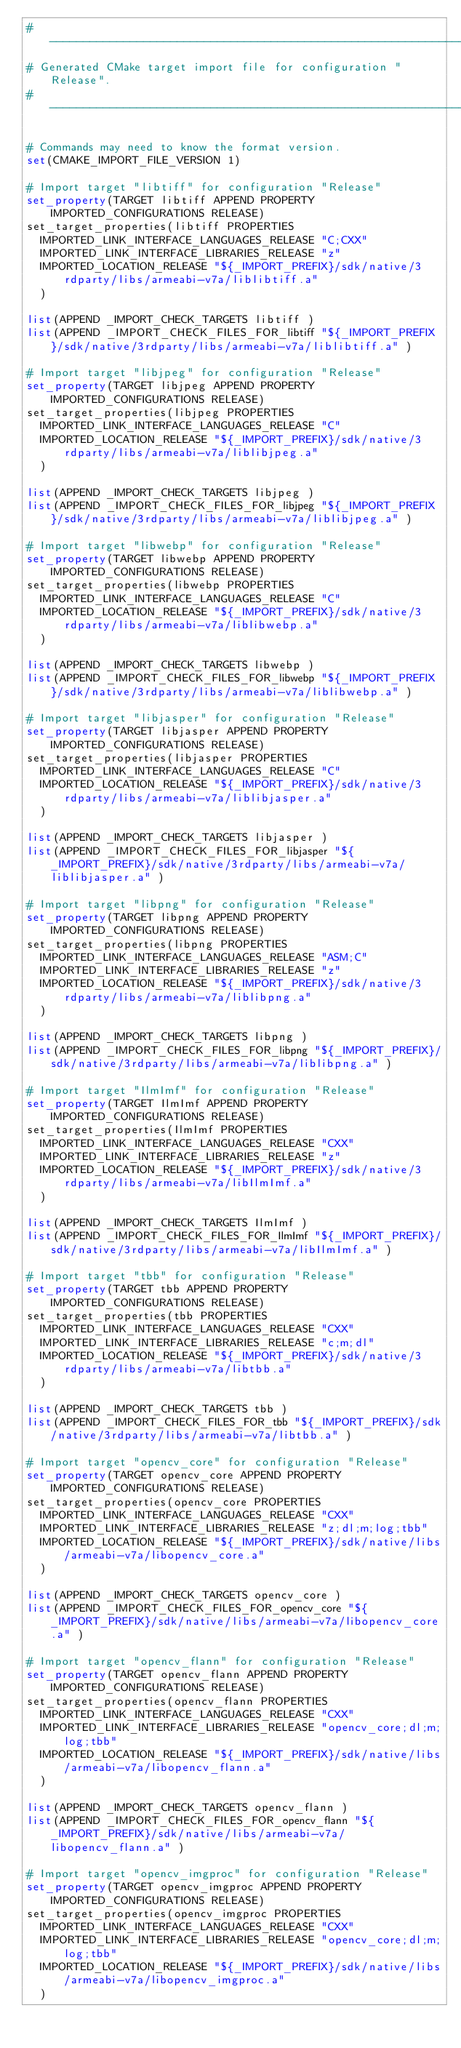Convert code to text. <code><loc_0><loc_0><loc_500><loc_500><_CMake_>#----------------------------------------------------------------
# Generated CMake target import file for configuration "Release".
#----------------------------------------------------------------

# Commands may need to know the format version.
set(CMAKE_IMPORT_FILE_VERSION 1)

# Import target "libtiff" for configuration "Release"
set_property(TARGET libtiff APPEND PROPERTY IMPORTED_CONFIGURATIONS RELEASE)
set_target_properties(libtiff PROPERTIES
  IMPORTED_LINK_INTERFACE_LANGUAGES_RELEASE "C;CXX"
  IMPORTED_LINK_INTERFACE_LIBRARIES_RELEASE "z"
  IMPORTED_LOCATION_RELEASE "${_IMPORT_PREFIX}/sdk/native/3rdparty/libs/armeabi-v7a/liblibtiff.a"
  )

list(APPEND _IMPORT_CHECK_TARGETS libtiff )
list(APPEND _IMPORT_CHECK_FILES_FOR_libtiff "${_IMPORT_PREFIX}/sdk/native/3rdparty/libs/armeabi-v7a/liblibtiff.a" )

# Import target "libjpeg" for configuration "Release"
set_property(TARGET libjpeg APPEND PROPERTY IMPORTED_CONFIGURATIONS RELEASE)
set_target_properties(libjpeg PROPERTIES
  IMPORTED_LINK_INTERFACE_LANGUAGES_RELEASE "C"
  IMPORTED_LOCATION_RELEASE "${_IMPORT_PREFIX}/sdk/native/3rdparty/libs/armeabi-v7a/liblibjpeg.a"
  )

list(APPEND _IMPORT_CHECK_TARGETS libjpeg )
list(APPEND _IMPORT_CHECK_FILES_FOR_libjpeg "${_IMPORT_PREFIX}/sdk/native/3rdparty/libs/armeabi-v7a/liblibjpeg.a" )

# Import target "libwebp" for configuration "Release"
set_property(TARGET libwebp APPEND PROPERTY IMPORTED_CONFIGURATIONS RELEASE)
set_target_properties(libwebp PROPERTIES
  IMPORTED_LINK_INTERFACE_LANGUAGES_RELEASE "C"
  IMPORTED_LOCATION_RELEASE "${_IMPORT_PREFIX}/sdk/native/3rdparty/libs/armeabi-v7a/liblibwebp.a"
  )

list(APPEND _IMPORT_CHECK_TARGETS libwebp )
list(APPEND _IMPORT_CHECK_FILES_FOR_libwebp "${_IMPORT_PREFIX}/sdk/native/3rdparty/libs/armeabi-v7a/liblibwebp.a" )

# Import target "libjasper" for configuration "Release"
set_property(TARGET libjasper APPEND PROPERTY IMPORTED_CONFIGURATIONS RELEASE)
set_target_properties(libjasper PROPERTIES
  IMPORTED_LINK_INTERFACE_LANGUAGES_RELEASE "C"
  IMPORTED_LOCATION_RELEASE "${_IMPORT_PREFIX}/sdk/native/3rdparty/libs/armeabi-v7a/liblibjasper.a"
  )

list(APPEND _IMPORT_CHECK_TARGETS libjasper )
list(APPEND _IMPORT_CHECK_FILES_FOR_libjasper "${_IMPORT_PREFIX}/sdk/native/3rdparty/libs/armeabi-v7a/liblibjasper.a" )

# Import target "libpng" for configuration "Release"
set_property(TARGET libpng APPEND PROPERTY IMPORTED_CONFIGURATIONS RELEASE)
set_target_properties(libpng PROPERTIES
  IMPORTED_LINK_INTERFACE_LANGUAGES_RELEASE "ASM;C"
  IMPORTED_LINK_INTERFACE_LIBRARIES_RELEASE "z"
  IMPORTED_LOCATION_RELEASE "${_IMPORT_PREFIX}/sdk/native/3rdparty/libs/armeabi-v7a/liblibpng.a"
  )

list(APPEND _IMPORT_CHECK_TARGETS libpng )
list(APPEND _IMPORT_CHECK_FILES_FOR_libpng "${_IMPORT_PREFIX}/sdk/native/3rdparty/libs/armeabi-v7a/liblibpng.a" )

# Import target "IlmImf" for configuration "Release"
set_property(TARGET IlmImf APPEND PROPERTY IMPORTED_CONFIGURATIONS RELEASE)
set_target_properties(IlmImf PROPERTIES
  IMPORTED_LINK_INTERFACE_LANGUAGES_RELEASE "CXX"
  IMPORTED_LINK_INTERFACE_LIBRARIES_RELEASE "z"
  IMPORTED_LOCATION_RELEASE "${_IMPORT_PREFIX}/sdk/native/3rdparty/libs/armeabi-v7a/libIlmImf.a"
  )

list(APPEND _IMPORT_CHECK_TARGETS IlmImf )
list(APPEND _IMPORT_CHECK_FILES_FOR_IlmImf "${_IMPORT_PREFIX}/sdk/native/3rdparty/libs/armeabi-v7a/libIlmImf.a" )

# Import target "tbb" for configuration "Release"
set_property(TARGET tbb APPEND PROPERTY IMPORTED_CONFIGURATIONS RELEASE)
set_target_properties(tbb PROPERTIES
  IMPORTED_LINK_INTERFACE_LANGUAGES_RELEASE "CXX"
  IMPORTED_LINK_INTERFACE_LIBRARIES_RELEASE "c;m;dl"
  IMPORTED_LOCATION_RELEASE "${_IMPORT_PREFIX}/sdk/native/3rdparty/libs/armeabi-v7a/libtbb.a"
  )

list(APPEND _IMPORT_CHECK_TARGETS tbb )
list(APPEND _IMPORT_CHECK_FILES_FOR_tbb "${_IMPORT_PREFIX}/sdk/native/3rdparty/libs/armeabi-v7a/libtbb.a" )

# Import target "opencv_core" for configuration "Release"
set_property(TARGET opencv_core APPEND PROPERTY IMPORTED_CONFIGURATIONS RELEASE)
set_target_properties(opencv_core PROPERTIES
  IMPORTED_LINK_INTERFACE_LANGUAGES_RELEASE "CXX"
  IMPORTED_LINK_INTERFACE_LIBRARIES_RELEASE "z;dl;m;log;tbb"
  IMPORTED_LOCATION_RELEASE "${_IMPORT_PREFIX}/sdk/native/libs/armeabi-v7a/libopencv_core.a"
  )

list(APPEND _IMPORT_CHECK_TARGETS opencv_core )
list(APPEND _IMPORT_CHECK_FILES_FOR_opencv_core "${_IMPORT_PREFIX}/sdk/native/libs/armeabi-v7a/libopencv_core.a" )

# Import target "opencv_flann" for configuration "Release"
set_property(TARGET opencv_flann APPEND PROPERTY IMPORTED_CONFIGURATIONS RELEASE)
set_target_properties(opencv_flann PROPERTIES
  IMPORTED_LINK_INTERFACE_LANGUAGES_RELEASE "CXX"
  IMPORTED_LINK_INTERFACE_LIBRARIES_RELEASE "opencv_core;dl;m;log;tbb"
  IMPORTED_LOCATION_RELEASE "${_IMPORT_PREFIX}/sdk/native/libs/armeabi-v7a/libopencv_flann.a"
  )

list(APPEND _IMPORT_CHECK_TARGETS opencv_flann )
list(APPEND _IMPORT_CHECK_FILES_FOR_opencv_flann "${_IMPORT_PREFIX}/sdk/native/libs/armeabi-v7a/libopencv_flann.a" )

# Import target "opencv_imgproc" for configuration "Release"
set_property(TARGET opencv_imgproc APPEND PROPERTY IMPORTED_CONFIGURATIONS RELEASE)
set_target_properties(opencv_imgproc PROPERTIES
  IMPORTED_LINK_INTERFACE_LANGUAGES_RELEASE "CXX"
  IMPORTED_LINK_INTERFACE_LIBRARIES_RELEASE "opencv_core;dl;m;log;tbb"
  IMPORTED_LOCATION_RELEASE "${_IMPORT_PREFIX}/sdk/native/libs/armeabi-v7a/libopencv_imgproc.a"
  )
</code> 